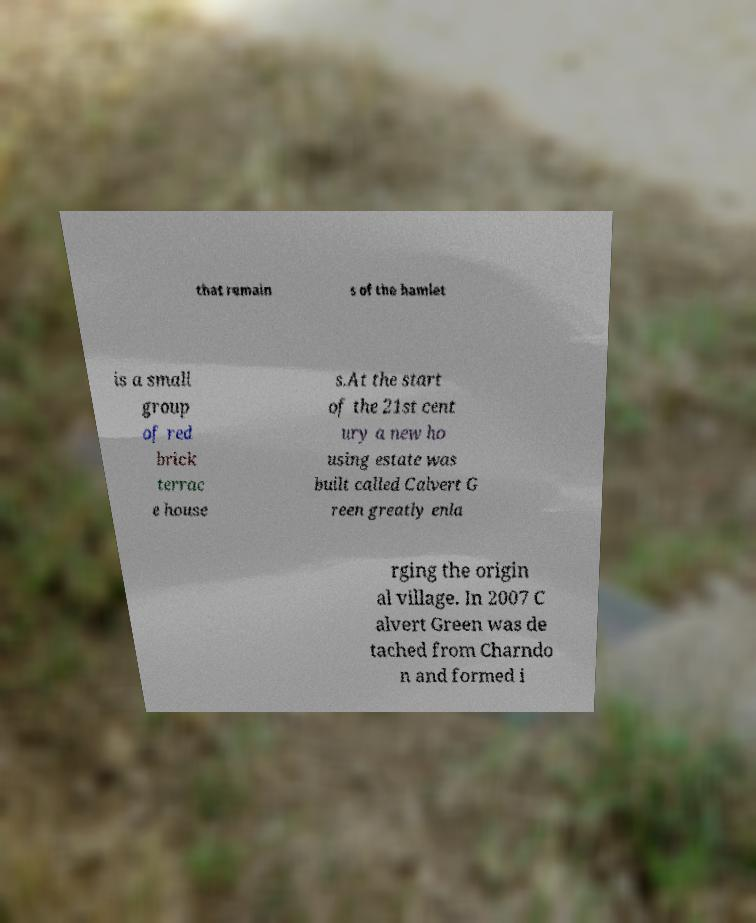Could you extract and type out the text from this image? that remain s of the hamlet is a small group of red brick terrac e house s.At the start of the 21st cent ury a new ho using estate was built called Calvert G reen greatly enla rging the origin al village. In 2007 C alvert Green was de tached from Charndo n and formed i 